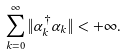<formula> <loc_0><loc_0><loc_500><loc_500>\sum _ { k = 0 } ^ { \infty } \| \alpha _ { k } ^ { \dagger } \alpha _ { k } \| < + \infty .</formula> 